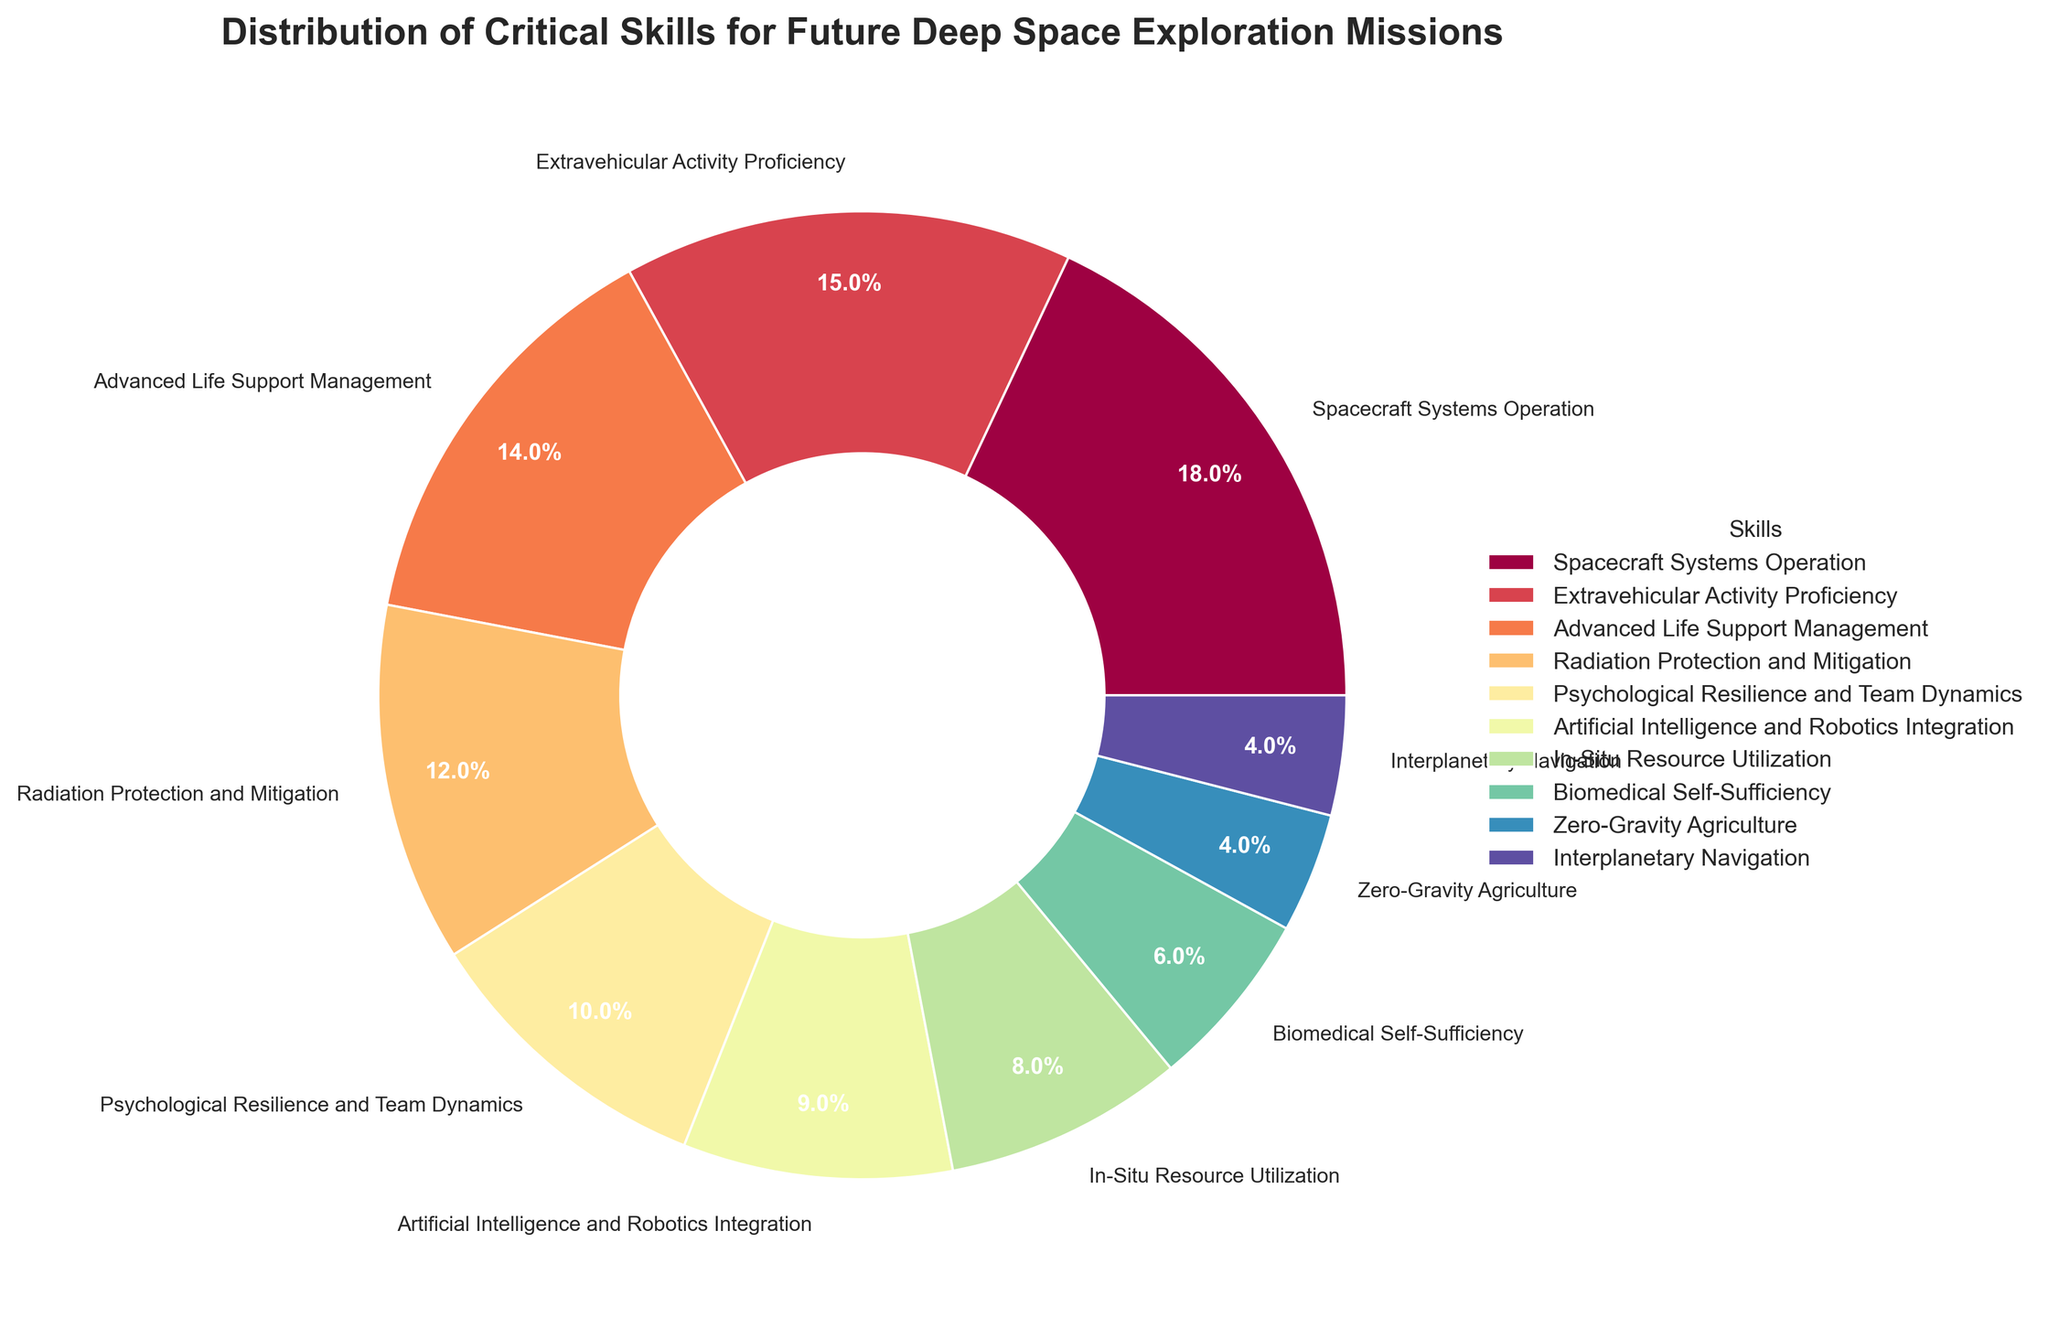Which skill occupies the largest portion in the pie chart? By visual inspection, the largest segment can be identified directly in the chart. The portion labeled "Spacecraft Systems Operation" is the largest.
Answer: Spacecraft Systems Operation Which skill combines to form the smallest third of the pie chart? The three smallest percentages are for Zero-Gravity Agriculture (4%), Interplanetary Navigation (4%), and Biomedical Self-Sufficiency (6%). Adding these, 4% + 4% + 6% = 14%, which is not enough, so including In-Situ Resource Utilization (8%) gives 4% + 4% + 6% + 8% = 22%, still not enough. Adding Artificial Intelligence and Robotics Integration (9%) results in 22% + 9% = 31%, which is slightly above the smallest third.
Answer: Zero-Gravity Agriculture & Interplanetary Navigation & Biomedical Self-Sufficiency & In-Situ Resource Utilization & Artificial Intelligence and Robotics Integration Which skill has a smaller share than Radiation Protection and Mitigation but larger than Biomedical Self-Sufficiency? Compare the percentages: Radiation Protection and Mitigation (12%), Biomedical Self-Sufficiency (6%). So, 9% Integration is in between these values.
Answer: Artificial Intelligence and Robotics Integration What is the total percentage of skills related to medical and life science aspects? Adding the relevant skills: Advanced Life Support Management (14%), Psychological Resilience and Team Dynamics (10%), Biomedical Self-Sufficiency (6%), Zero-Gravity Agriculture (4%). 14% + 10% + 6% + 4% = 34%.
Answer: 34% Which two skills add up to the same proportion as Extravehicular Activity Proficiency? Extravehicular Activity Proficiency is 15%. Look for a pair of values adding to this. The closest would be Zero-Gravity Agriculture (4%) and Interplanetary Navigation (4%), each too small.  Radiation Protection and Mitigation (12%) combined with Zero-Gravity Agriculture (4%) adds to 16% (close to 15%). Confirm as follows: Artificial Intelligence and Robotics Integration (9%) + In-Situ Resource Utilization (8%) = 17% also too high. Lastly, Biomedical Self-Sufficiency (6%) + Zero-Gravity Agriculture (4%) = 10% and adding Artificial Intelligence and Robotics Integration (9%) gives 10%+9%=15%. So this combination is the answer.
Answer: Artificial Intelligence and Robotics Integration and Biomedical Self-Sufficiency Which skill segments are directly adjacent to Spacecraft Systems Operation in the pie chart? Observing the chart, the adjacent segments to Spacecraft Systems Operation appear to be Extravehicular Activity Proficiency and Zero-Gravity Agriculture.
Answer: Extravehicular Activity Proficiency, Zero-Gravity Agriculture 